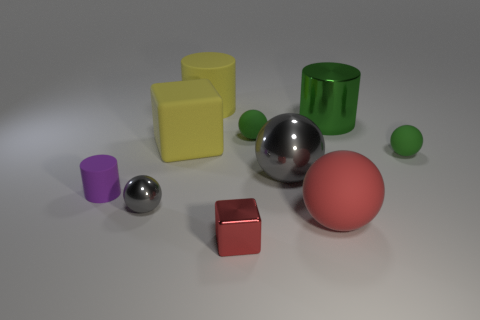What number of other things are there of the same size as the yellow rubber cylinder?
Provide a short and direct response. 4. What size is the matte cylinder that is the same color as the rubber block?
Give a very brief answer. Large. What number of small metallic things have the same color as the large rubber cube?
Keep it short and to the point. 0. The tiny red thing is what shape?
Your response must be concise. Cube. What is the color of the large rubber thing that is in front of the large rubber cylinder and behind the large matte sphere?
Give a very brief answer. Yellow. What is the large gray thing made of?
Provide a short and direct response. Metal. The matte object left of the tiny gray metal sphere has what shape?
Keep it short and to the point. Cylinder. The rubber sphere that is the same size as the yellow matte block is what color?
Offer a terse response. Red. Do the thing that is right of the green metal thing and the small cube have the same material?
Give a very brief answer. No. How big is the matte ball that is behind the tiny purple thing and in front of the large matte block?
Provide a succinct answer. Small. 